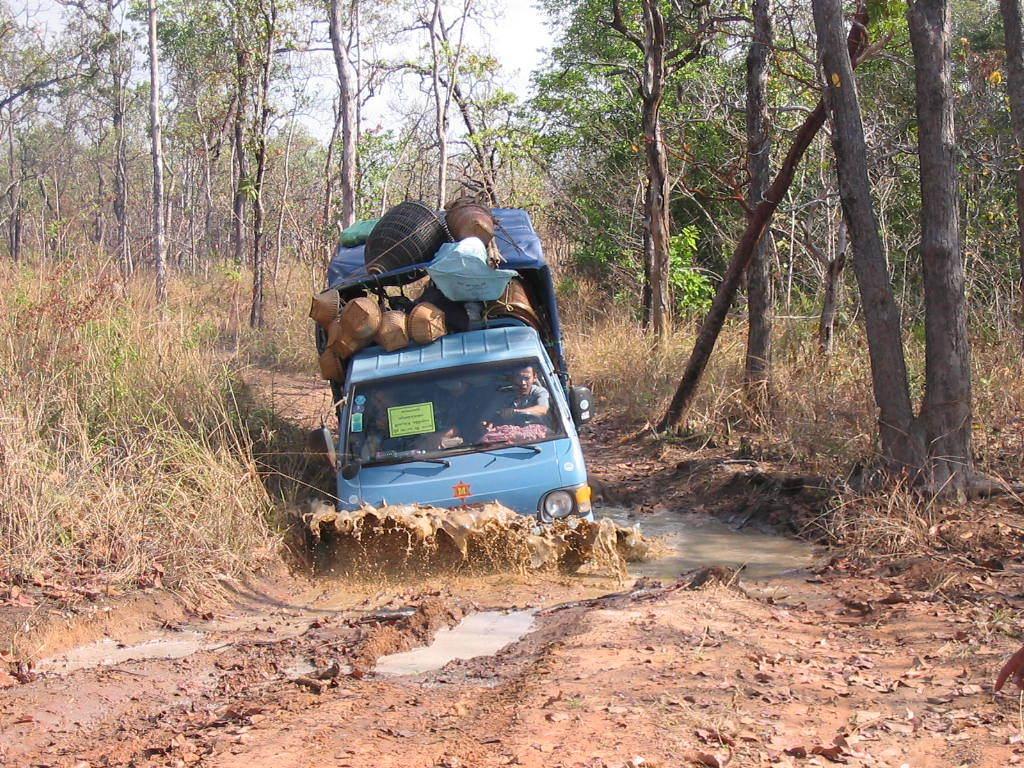How would you summarize this image in a sentence or two? In the center of the image we can see a vehicle in the water. Inside the vehicle, we can see a person is sitting. And we can see a few objects on the vehicle. In the background, we can see the sky, trees, grass, water and mud. 